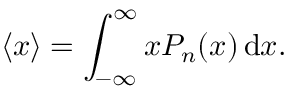<formula> <loc_0><loc_0><loc_500><loc_500>\langle x \rangle = \int _ { - \infty } ^ { \infty } x P _ { n } ( x ) \, d x .</formula> 